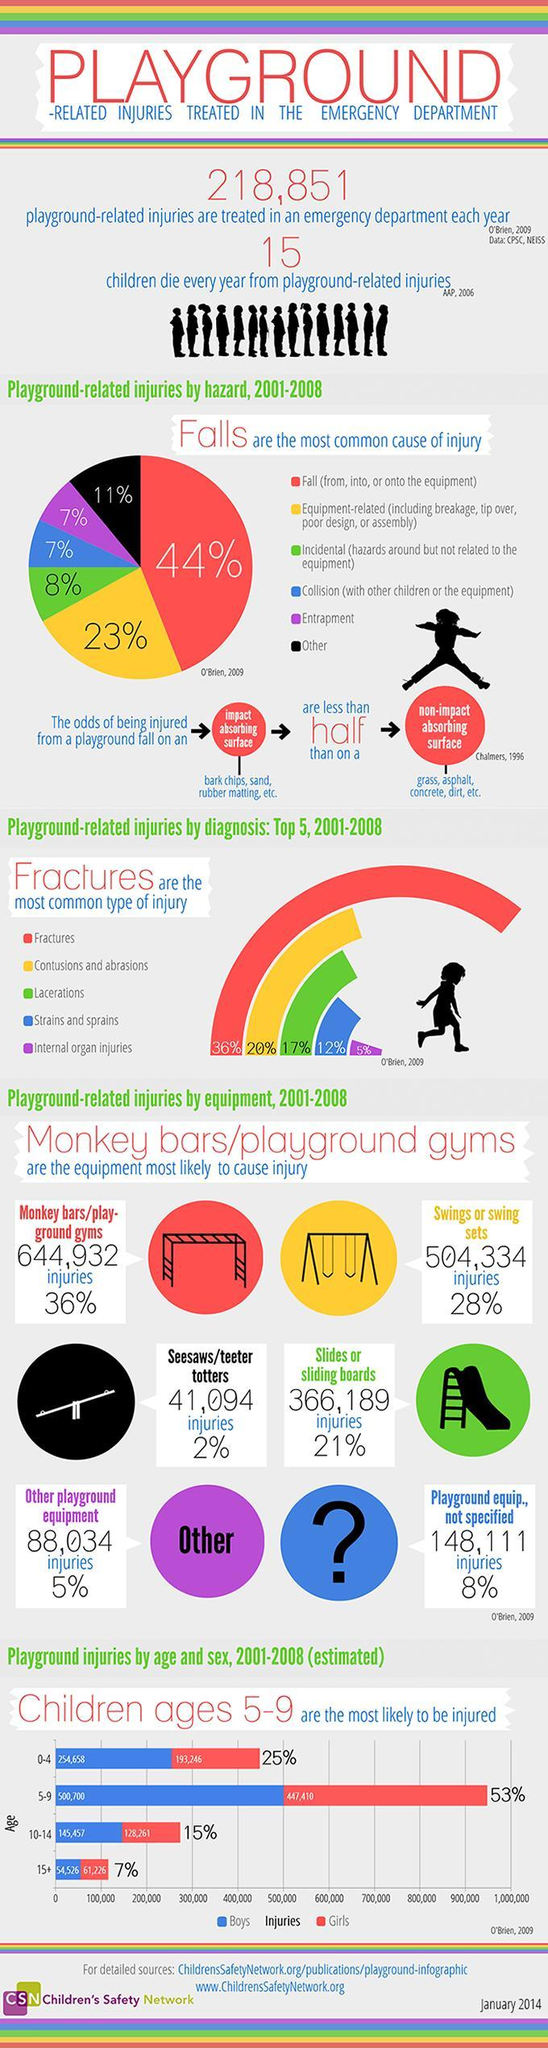What is the reason for 23% of playground related injuries?
Answer the question with a short phrase. equipment-related (including breakage, tip over, poor design, or assembly) Which surface reduces risk of injury - impact absorbing or non-impact absorbing? impact absorbing What type of surfaces are grass, asphalt, concrete, dirt etc.? non-impact absorbing surface What is the number of injuries reported due to swings or swing sets? 504,334 How many injuries were reported due to slides or sliding boards? 366,189 What is the reason for 44% of playground related injuries? Fall (from, into, or onto the equipment) 20% of playground injuries are of which type? contusions and abrasions what is the percentage of getting fractures in playground related injuries? 36% Which three impact absorbing surfaces are mentioned? bark chips, sand, rubber matting What percent of injuries are from monkey bars/playground gyms? 36% 